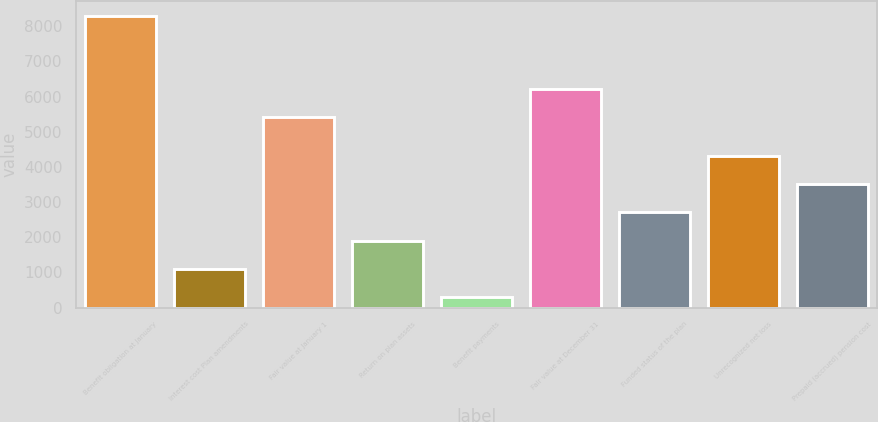<chart> <loc_0><loc_0><loc_500><loc_500><bar_chart><fcel>Benefit obligation at January<fcel>Interest cost Plan amendments<fcel>Fair value at January 1<fcel>Return on plan assets<fcel>Benefit payments<fcel>Fair value at December 31<fcel>Funded status of the plan<fcel>Unrecognized net loss<fcel>Prepaid (accrued) pension cost<nl><fcel>8288<fcel>1108.7<fcel>5426<fcel>1906.4<fcel>311<fcel>6223.7<fcel>2704.1<fcel>4299.5<fcel>3501.8<nl></chart> 